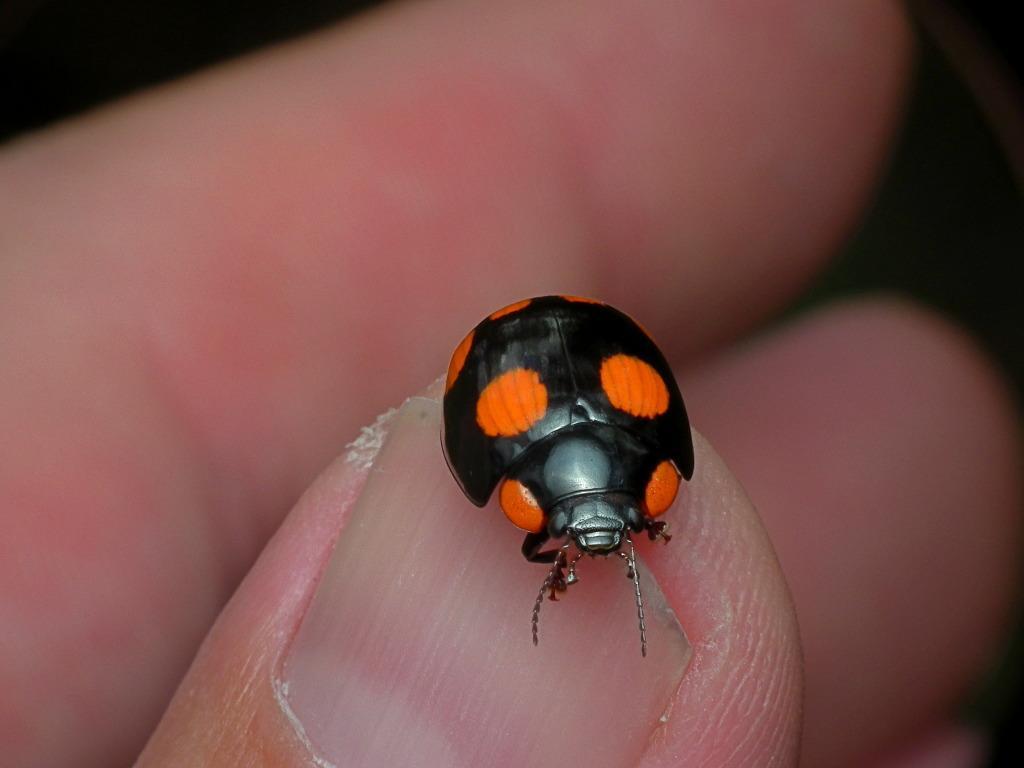Please provide a concise description of this image. This image consists of a person's hand. On one finger there is an insect. It is in black color. 